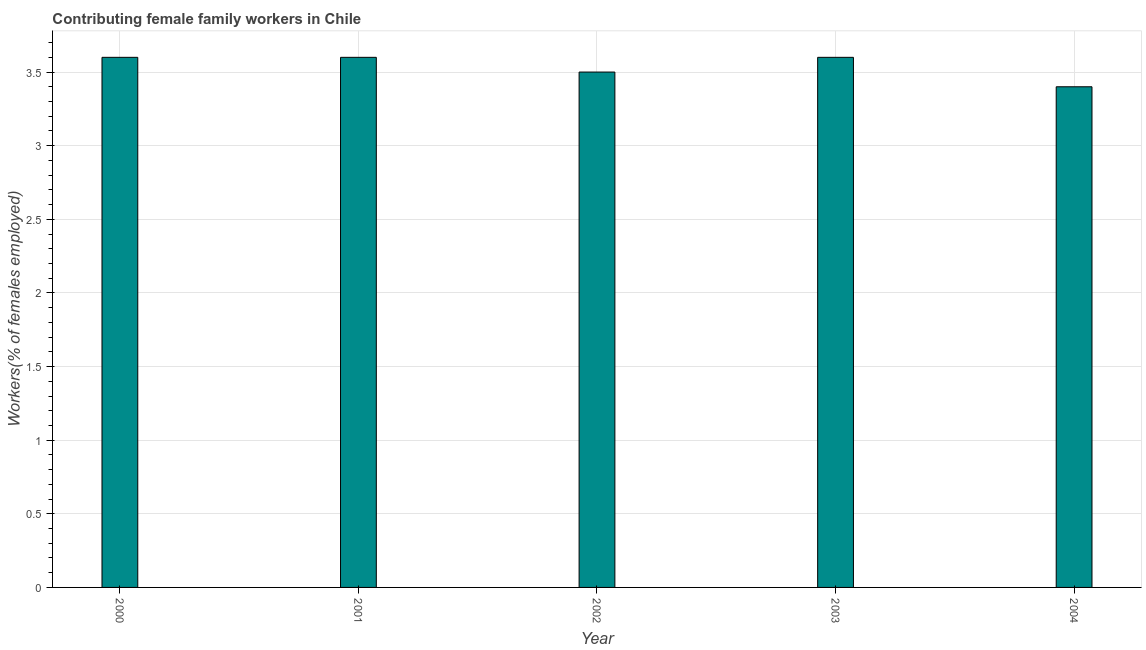Does the graph contain any zero values?
Your answer should be compact. No. Does the graph contain grids?
Give a very brief answer. Yes. What is the title of the graph?
Ensure brevity in your answer.  Contributing female family workers in Chile. What is the label or title of the X-axis?
Make the answer very short. Year. What is the label or title of the Y-axis?
Make the answer very short. Workers(% of females employed). What is the contributing female family workers in 2004?
Make the answer very short. 3.4. Across all years, what is the maximum contributing female family workers?
Offer a terse response. 3.6. Across all years, what is the minimum contributing female family workers?
Your answer should be compact. 3.4. What is the sum of the contributing female family workers?
Your answer should be compact. 17.7. What is the average contributing female family workers per year?
Provide a succinct answer. 3.54. What is the median contributing female family workers?
Make the answer very short. 3.6. In how many years, is the contributing female family workers greater than 3.6 %?
Your response must be concise. 0. What is the ratio of the contributing female family workers in 2000 to that in 2003?
Make the answer very short. 1. Is the contributing female family workers in 2002 less than that in 2004?
Give a very brief answer. No. Is the sum of the contributing female family workers in 2000 and 2001 greater than the maximum contributing female family workers across all years?
Ensure brevity in your answer.  Yes. What is the difference between the highest and the lowest contributing female family workers?
Your response must be concise. 0.2. In how many years, is the contributing female family workers greater than the average contributing female family workers taken over all years?
Provide a succinct answer. 3. Are all the bars in the graph horizontal?
Make the answer very short. No. How many years are there in the graph?
Ensure brevity in your answer.  5. Are the values on the major ticks of Y-axis written in scientific E-notation?
Your answer should be compact. No. What is the Workers(% of females employed) in 2000?
Keep it short and to the point. 3.6. What is the Workers(% of females employed) of 2001?
Your response must be concise. 3.6. What is the Workers(% of females employed) in 2003?
Offer a very short reply. 3.6. What is the Workers(% of females employed) of 2004?
Your answer should be very brief. 3.4. What is the difference between the Workers(% of females employed) in 2000 and 2002?
Ensure brevity in your answer.  0.1. What is the difference between the Workers(% of females employed) in 2000 and 2003?
Your response must be concise. 0. What is the difference between the Workers(% of females employed) in 2000 and 2004?
Provide a succinct answer. 0.2. What is the difference between the Workers(% of females employed) in 2001 and 2002?
Offer a terse response. 0.1. What is the difference between the Workers(% of females employed) in 2001 and 2004?
Your response must be concise. 0.2. What is the difference between the Workers(% of females employed) in 2002 and 2004?
Keep it short and to the point. 0.1. What is the ratio of the Workers(% of females employed) in 2000 to that in 2003?
Give a very brief answer. 1. What is the ratio of the Workers(% of females employed) in 2000 to that in 2004?
Offer a terse response. 1.06. What is the ratio of the Workers(% of females employed) in 2001 to that in 2004?
Keep it short and to the point. 1.06. What is the ratio of the Workers(% of females employed) in 2002 to that in 2004?
Ensure brevity in your answer.  1.03. What is the ratio of the Workers(% of females employed) in 2003 to that in 2004?
Your response must be concise. 1.06. 